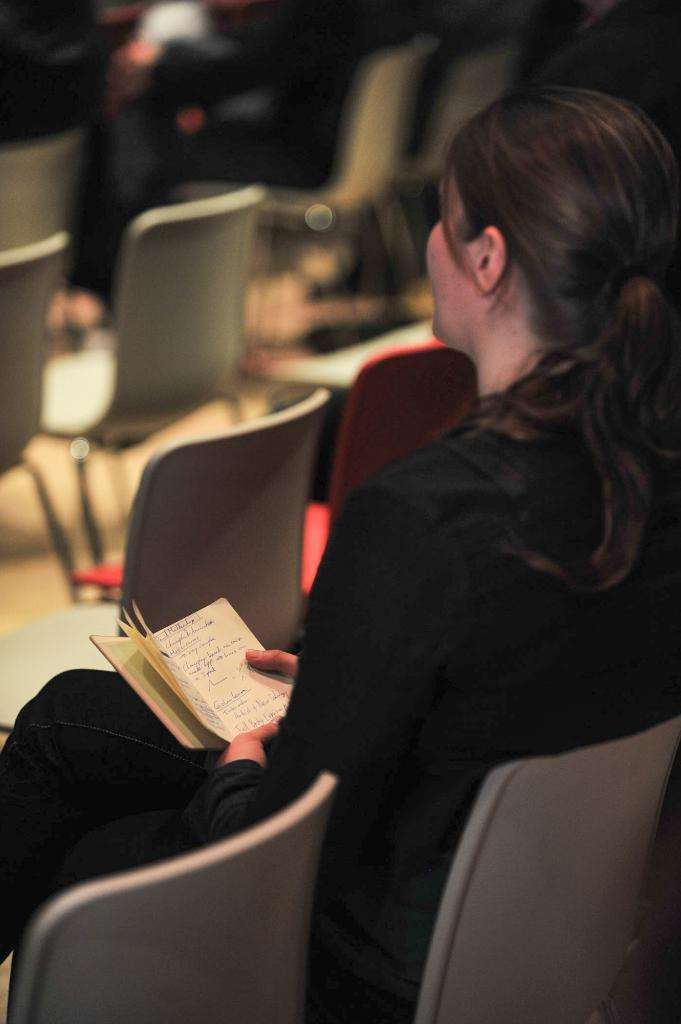Who is present in the image? There is a woman in the image. What is the woman doing in the image? The woman is sitting in a chair and holding a book in her hands. How many chairs are visible in the image? There are chairs in the image. What color is the crayon the woman is using to draw in the image? There is no crayon present in the image, and the woman is not drawing. What sense is the woman experiencing while sitting in the chair? The image does not provide information about the woman's senses or experiences. 